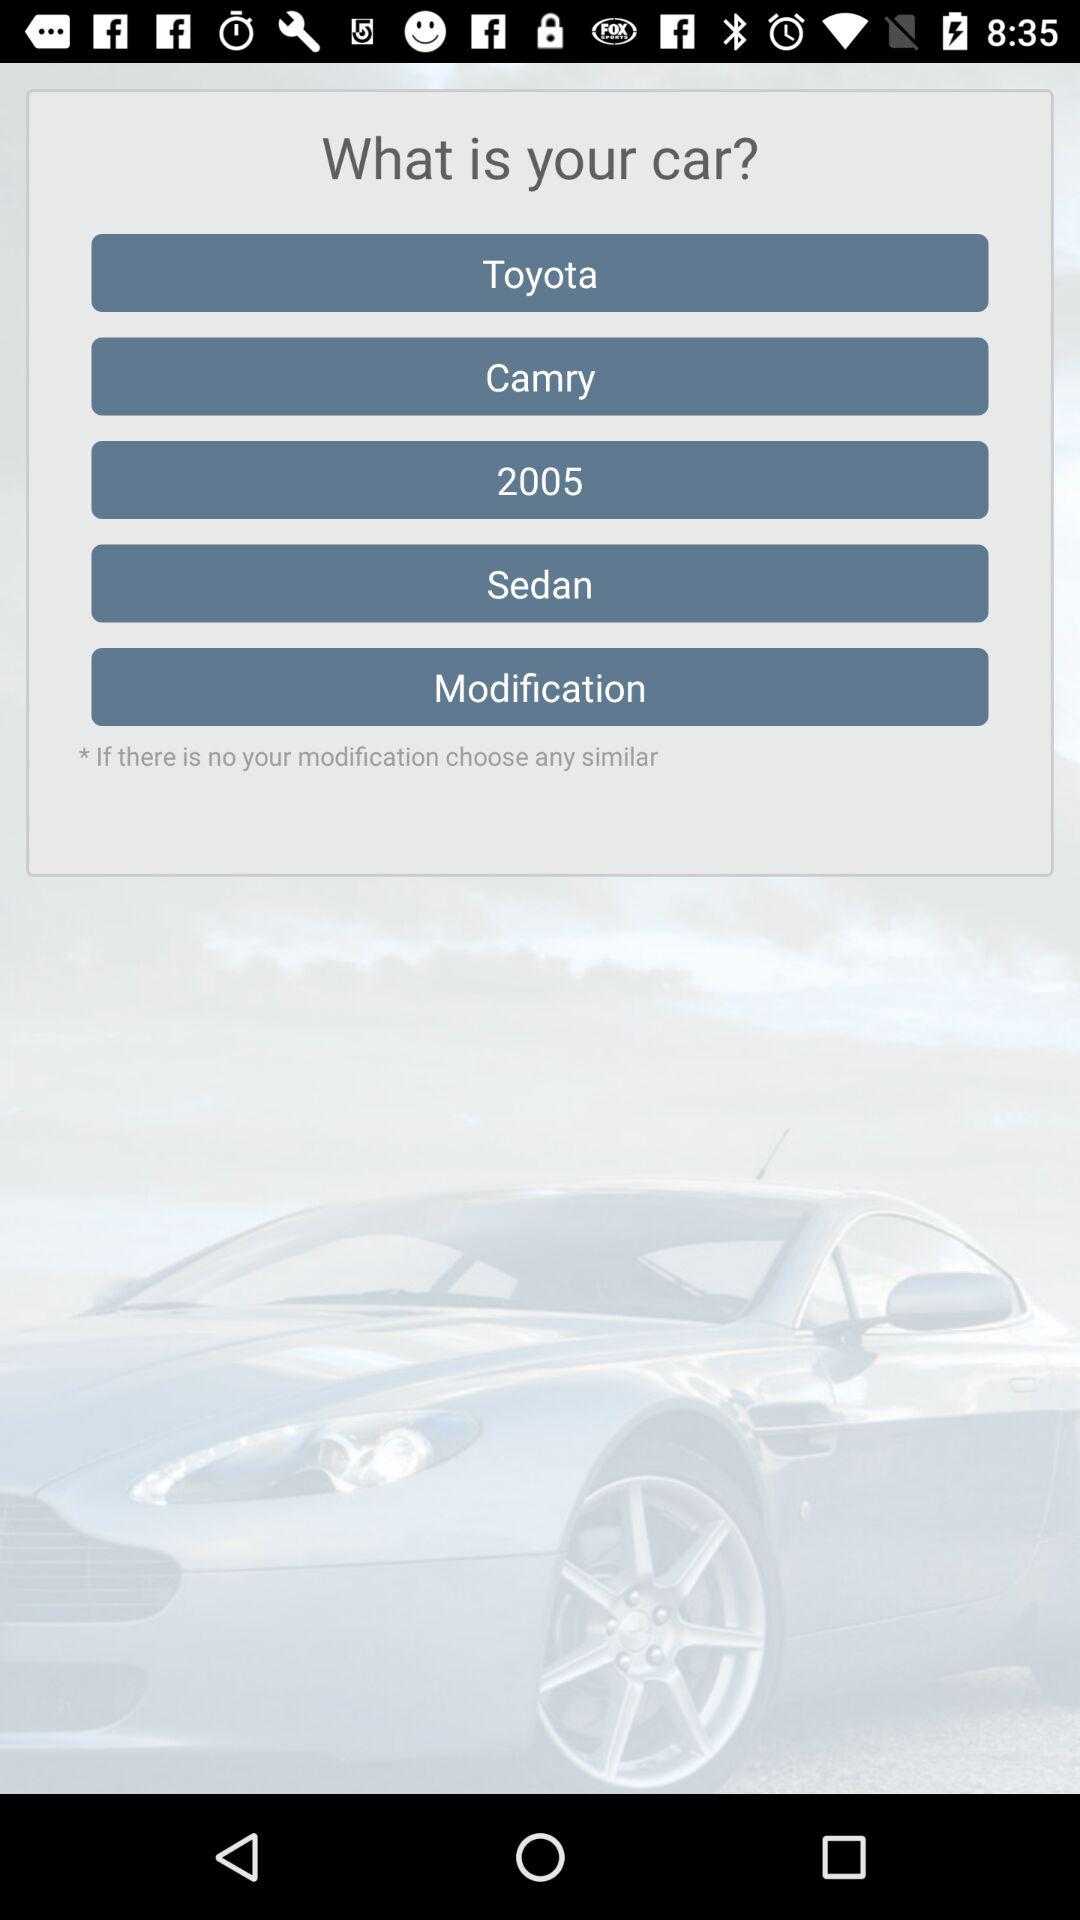What is the manufacturing year? The manufacturing year is 2005. 